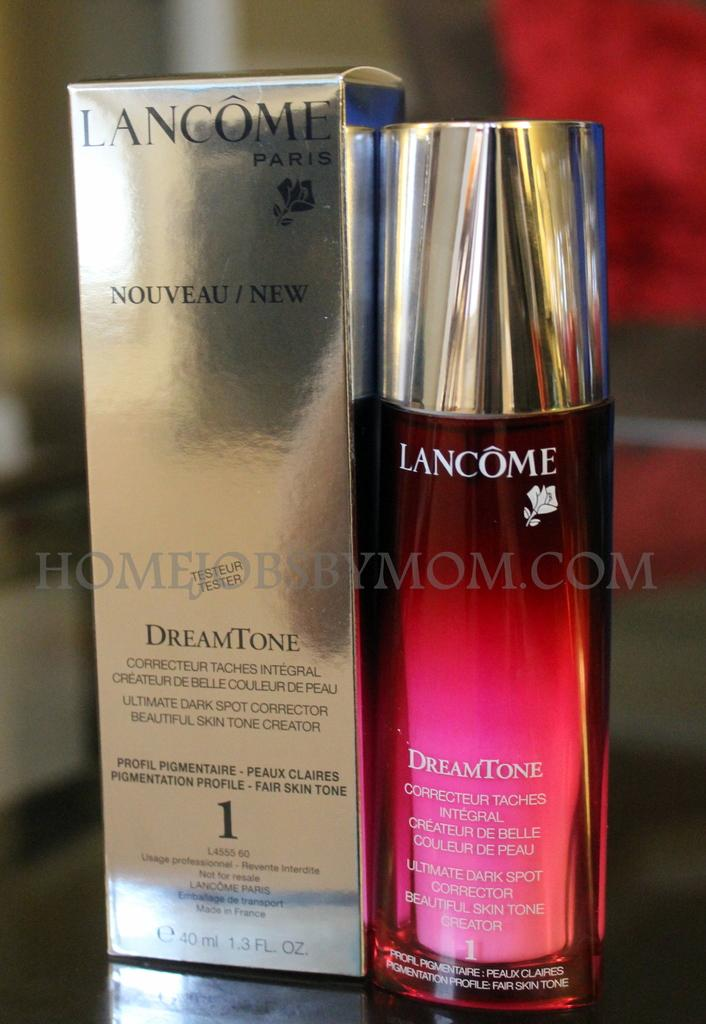Provide a one-sentence caption for the provided image. A bottle of LANCOME is sitting next to the box for the scent DreamTone. 